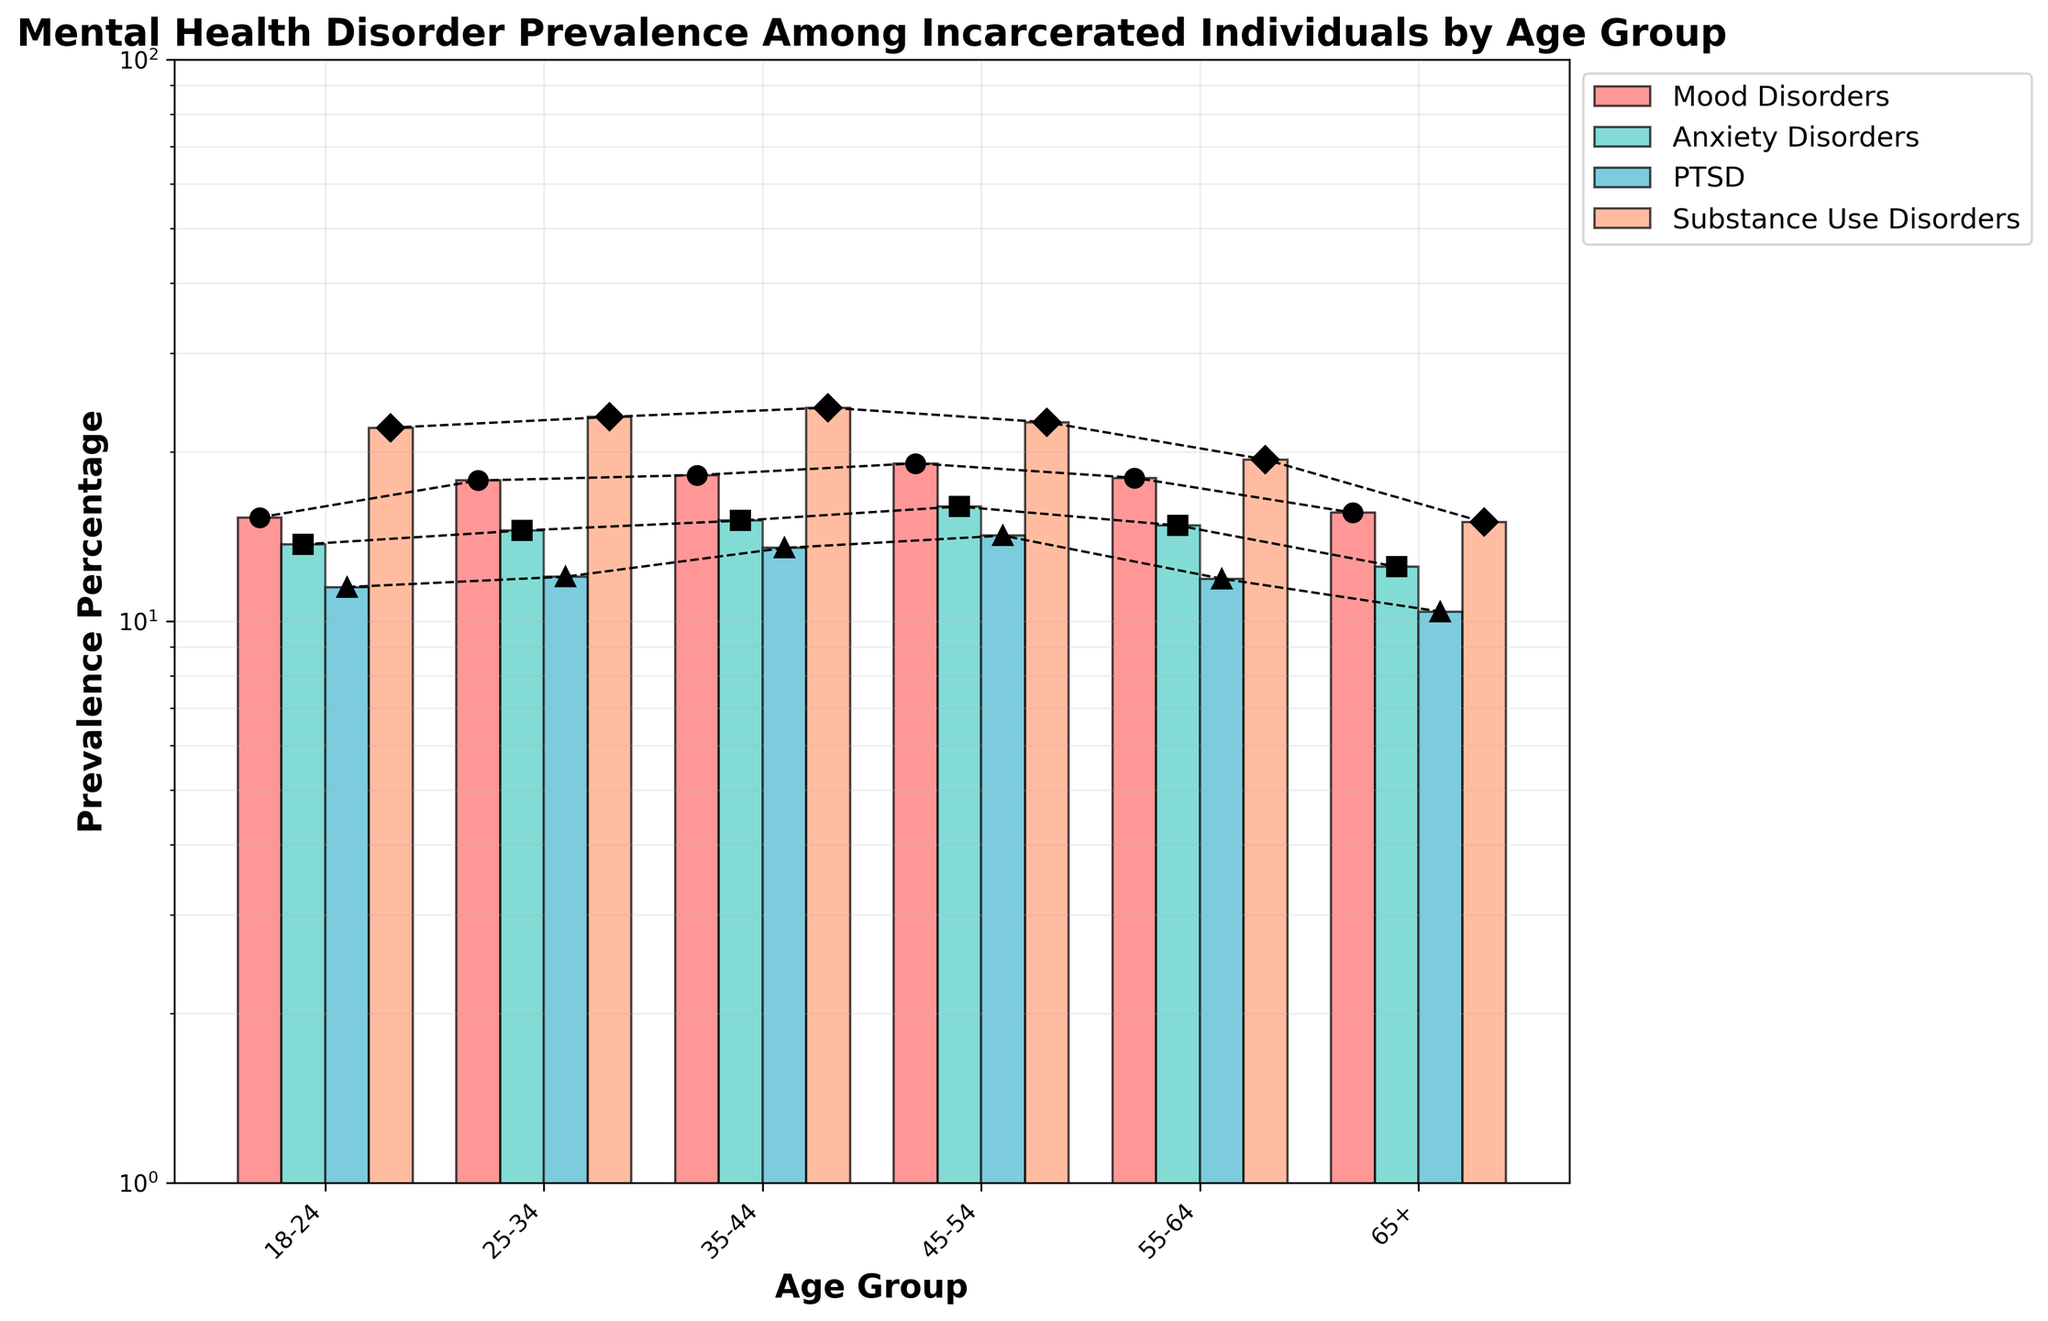what is the title of the plot? The title is visibly located at the top of the chart and is in bold text. It provides a summary description of the plot's subject.
Answer: Mental Health Disorder Prevalence Among Incarcerated Individuals by Age Group What is the prevalence percentage of substance use disorders for the age group 18-24? Identifying the colored bars related to "Substance Use Disorders" and finding the corresponding bar for the age group "18-24".
Answer: 22.1% Which disorder has the highest prevalence percentage in the age group 45-54? We examine the bars corresponding to each mental health disorder for the age group "45-54" and identify the tallest bar in that cluster.
Answer: Mood Disorders How does the prevalence of anxiety disorders change from age group 18-24 to age group 25-34? We compare the heights of the bars corresponding to "Anxiety Disorders" for both age groups and note the difference.
Answer: Increases from 13.7% to 14.5% What can be observed about the trend of mood disorders as age increases? We look at the heights of the bars corresponding to "Mood Disorders" across all age groups and observe if they increase, decrease, or fluctuate.
Answer: Generally increasing until 45-54, then decreasing Compare the highest prevalence percentage between PTSD and Mood Disorders for age group 35-44. Which is higher? Analyzing the specific age group "35-44", we compare the heights of the bars for PTSD and Mood Disorders, determining which bar is taller.
Answer: Mood Disorders Do any age groups have a higher prevalence of PTSD over Anxiety Disorders? For each age group, we compare the heights of the bars for "PTSD" and "Anxiety Disorders" to see if PTSD is higher.
Answer: No Which age group experiences the lowest prevalence of Substance Use Disorders? Identifying the shortest bar within the "Substance Use Disorders" category across all age groups.
Answer: 65+ What is the second most prevalent disorder for the age group 25-34? For the age group "25-34", we rank the bars in descending order of height and identify the second tallest bar.
Answer: Anxiety Disorders What is the general pattern for substance use disorders across different age groups? Observing the heights of the bars for "Substance Use Disorders" across all age groups to notice any increasing, decreasing trend or fluctuations.
Answer: Generally decreasing with age 